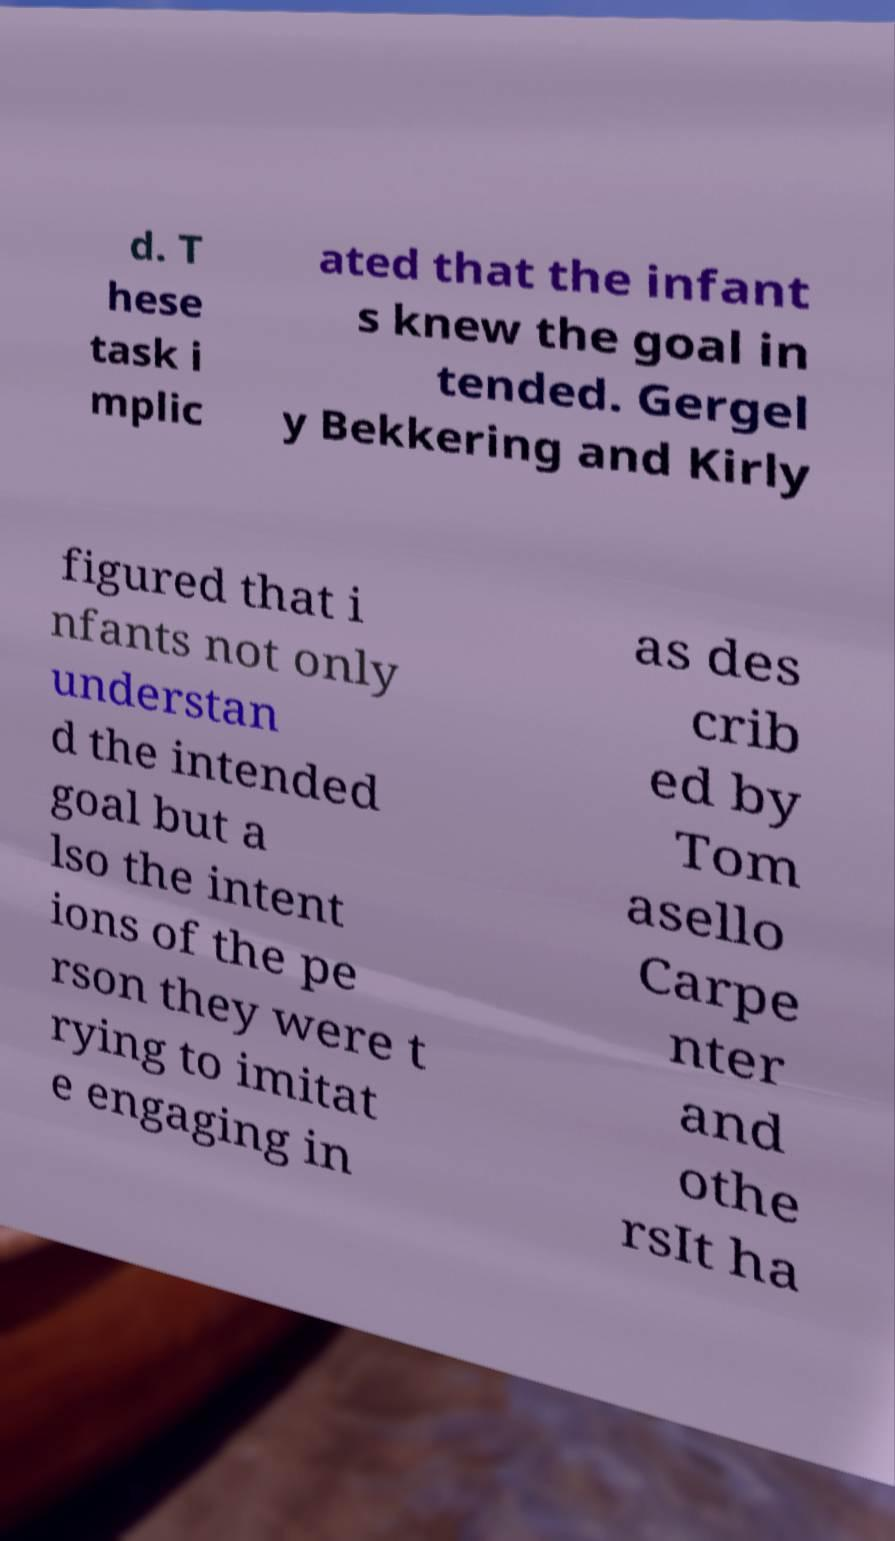Could you extract and type out the text from this image? d. T hese task i mplic ated that the infant s knew the goal in tended. Gergel y Bekkering and Kirly figured that i nfants not only understan d the intended goal but a lso the intent ions of the pe rson they were t rying to imitat e engaging in as des crib ed by Tom asello Carpe nter and othe rsIt ha 